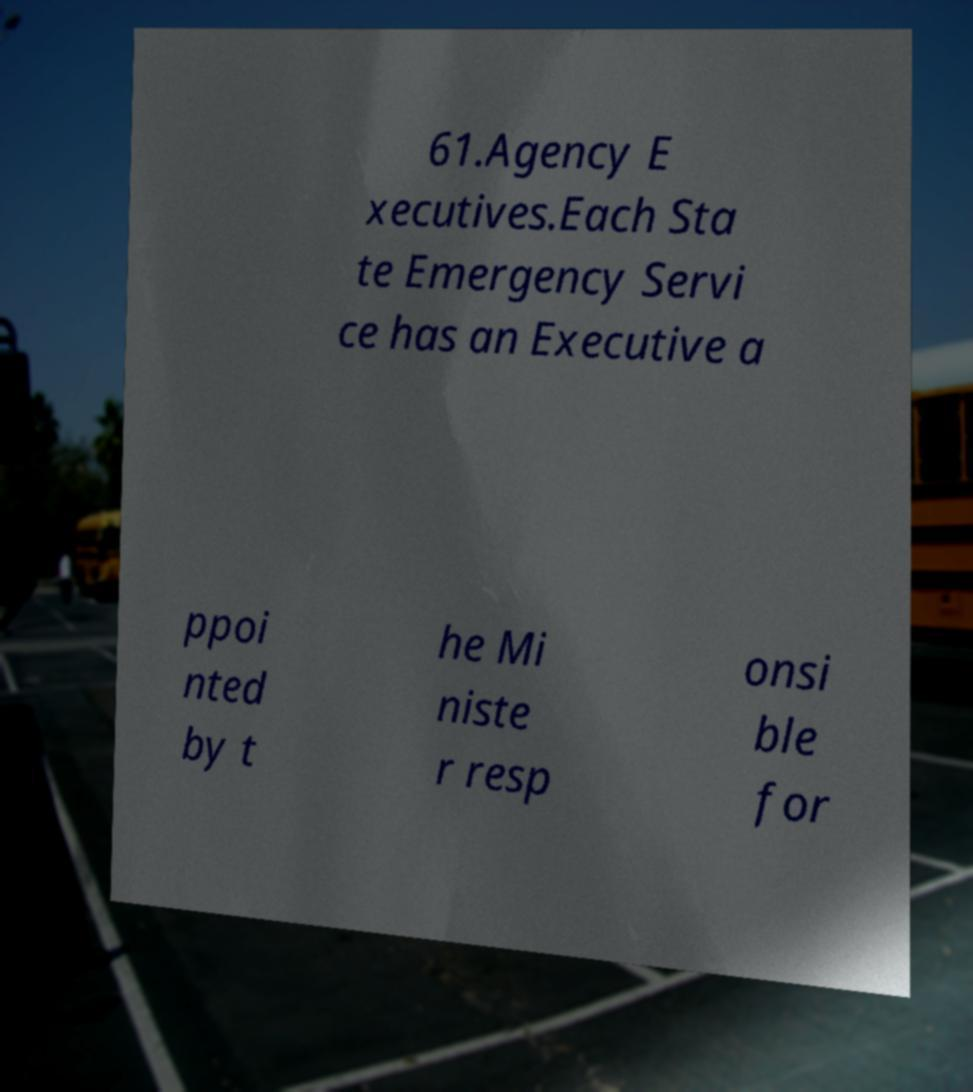Could you extract and type out the text from this image? 61.Agency E xecutives.Each Sta te Emergency Servi ce has an Executive a ppoi nted by t he Mi niste r resp onsi ble for 